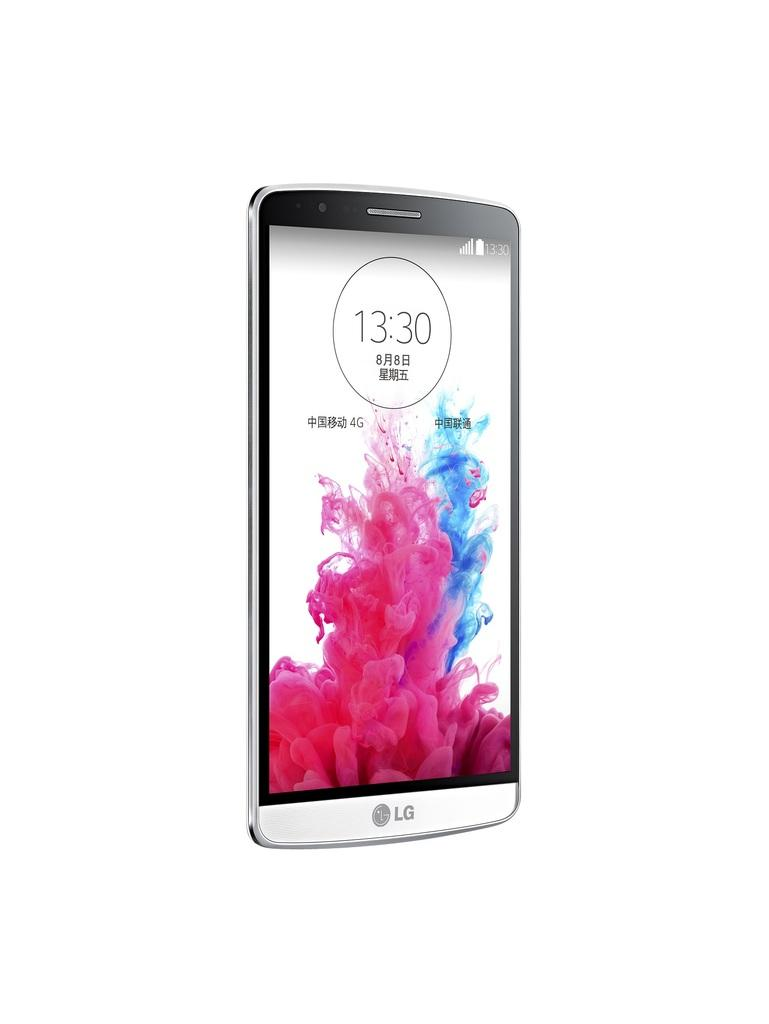<image>
Create a compact narrative representing the image presented. an LG cell phone with a fiery display showing 13:30 